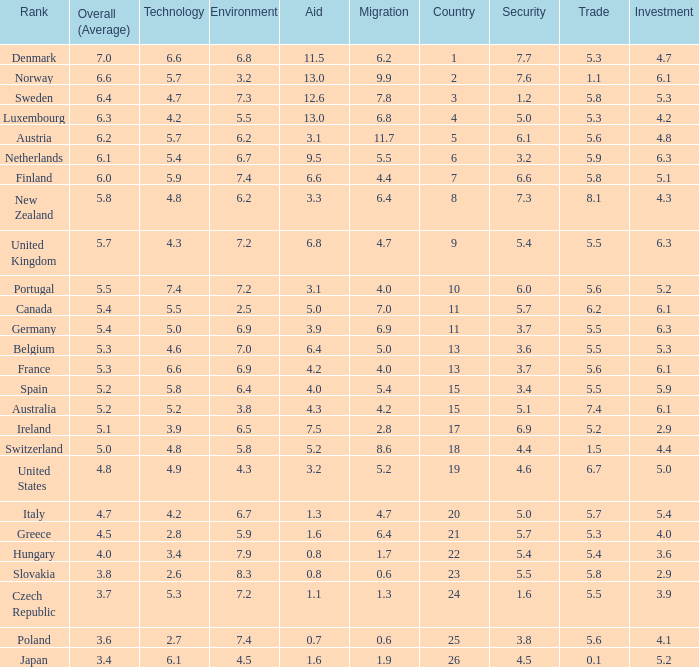What is the environment rating of the country with an overall average rating of 4.7? 6.7. 